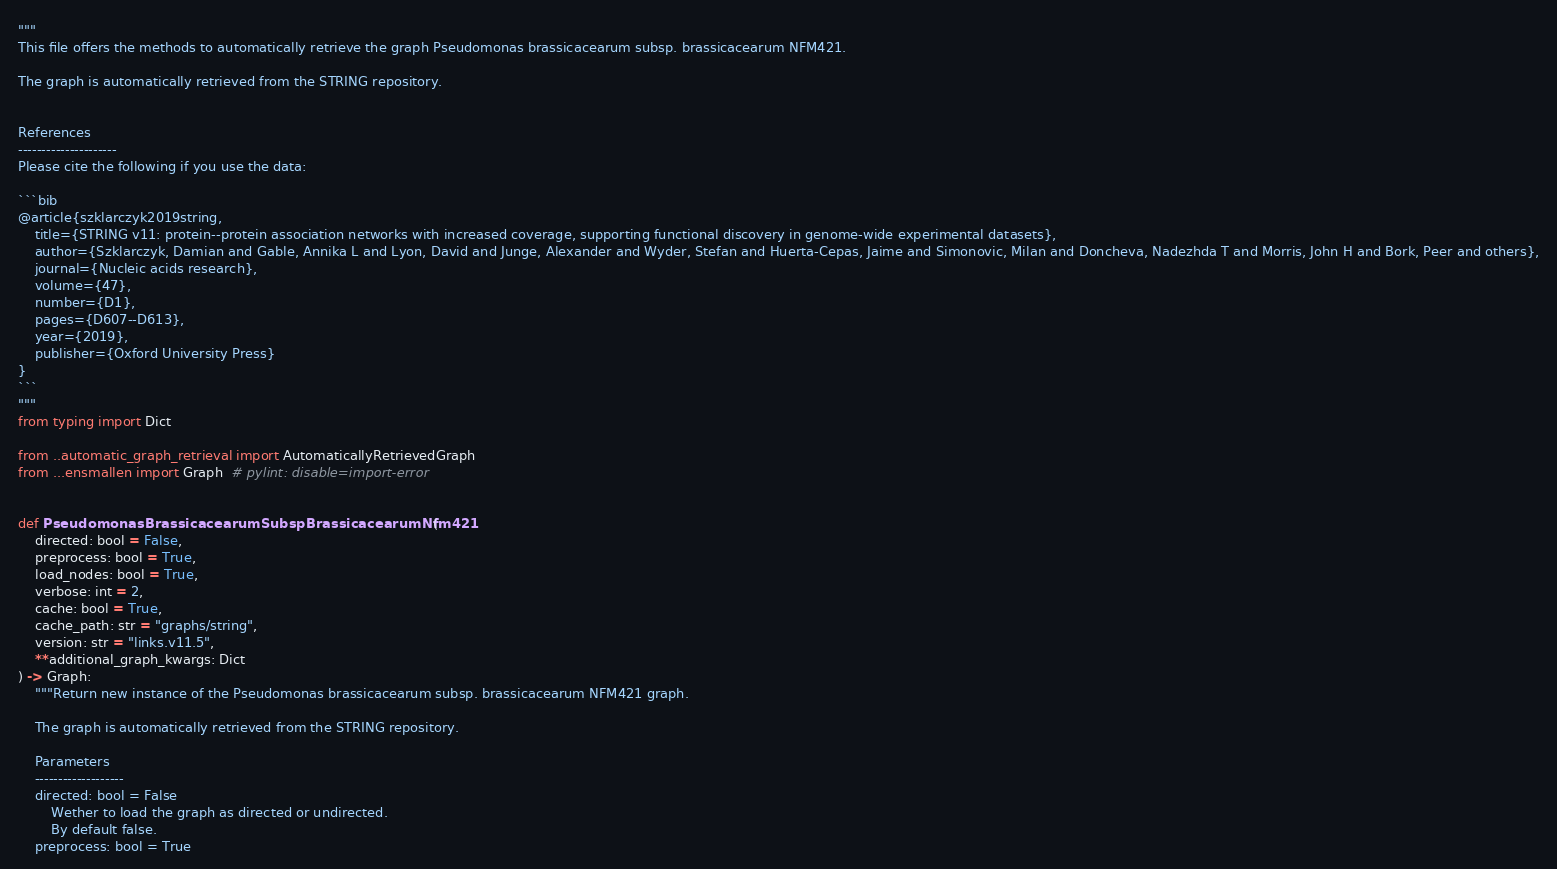Convert code to text. <code><loc_0><loc_0><loc_500><loc_500><_Python_>"""
This file offers the methods to automatically retrieve the graph Pseudomonas brassicacearum subsp. brassicacearum NFM421.

The graph is automatically retrieved from the STRING repository. 


References
---------------------
Please cite the following if you use the data:

```bib
@article{szklarczyk2019string,
    title={STRING v11: protein--protein association networks with increased coverage, supporting functional discovery in genome-wide experimental datasets},
    author={Szklarczyk, Damian and Gable, Annika L and Lyon, David and Junge, Alexander and Wyder, Stefan and Huerta-Cepas, Jaime and Simonovic, Milan and Doncheva, Nadezhda T and Morris, John H and Bork, Peer and others},
    journal={Nucleic acids research},
    volume={47},
    number={D1},
    pages={D607--D613},
    year={2019},
    publisher={Oxford University Press}
}
```
"""
from typing import Dict

from ..automatic_graph_retrieval import AutomaticallyRetrievedGraph
from ...ensmallen import Graph  # pylint: disable=import-error


def PseudomonasBrassicacearumSubspBrassicacearumNfm421(
    directed: bool = False,
    preprocess: bool = True,
    load_nodes: bool = True,
    verbose: int = 2,
    cache: bool = True,
    cache_path: str = "graphs/string",
    version: str = "links.v11.5",
    **additional_graph_kwargs: Dict
) -> Graph:
    """Return new instance of the Pseudomonas brassicacearum subsp. brassicacearum NFM421 graph.

    The graph is automatically retrieved from the STRING repository.	

    Parameters
    -------------------
    directed: bool = False
        Wether to load the graph as directed or undirected.
        By default false.
    preprocess: bool = True</code> 